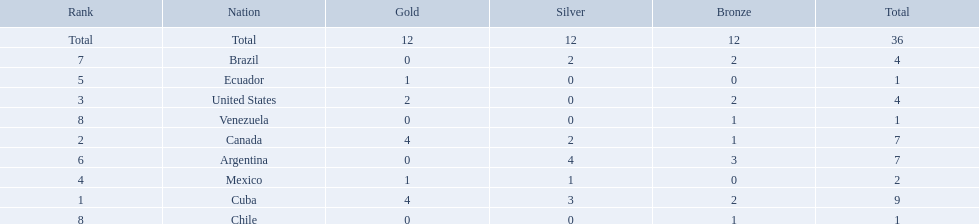Which nations competed in the 2011 pan american games? Cuba, Canada, United States, Mexico, Ecuador, Argentina, Brazil, Chile, Venezuela. Of these nations which ones won gold? Cuba, Canada, United States, Mexico, Ecuador. Which nation of the ones that won gold did not win silver? United States. What were all of the nations involved in the canoeing at the 2011 pan american games? Cuba, Canada, United States, Mexico, Ecuador, Argentina, Brazil, Chile, Venezuela, Total. Of these, which had a numbered rank? Cuba, Canada, United States, Mexico, Ecuador, Argentina, Brazil, Chile, Venezuela. Write the full table. {'header': ['Rank', 'Nation', 'Gold', 'Silver', 'Bronze', 'Total'], 'rows': [['Total', 'Total', '12', '12', '12', '36'], ['7', 'Brazil', '0', '2', '2', '4'], ['5', 'Ecuador', '1', '0', '0', '1'], ['3', 'United States', '2', '0', '2', '4'], ['8', 'Venezuela', '0', '0', '1', '1'], ['2', 'Canada', '4', '2', '1', '7'], ['6', 'Argentina', '0', '4', '3', '7'], ['4', 'Mexico', '1', '1', '0', '2'], ['1', 'Cuba', '4', '3', '2', '9'], ['8', 'Chile', '0', '0', '1', '1']]} From these, which had the highest number of bronze? Argentina. 